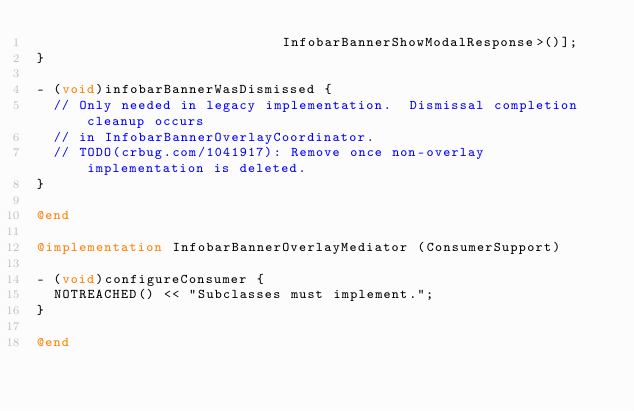<code> <loc_0><loc_0><loc_500><loc_500><_ObjectiveC_>                             InfobarBannerShowModalResponse>()];
}

- (void)infobarBannerWasDismissed {
  // Only needed in legacy implementation.  Dismissal completion cleanup occurs
  // in InfobarBannerOverlayCoordinator.
  // TODO(crbug.com/1041917): Remove once non-overlay implementation is deleted.
}

@end

@implementation InfobarBannerOverlayMediator (ConsumerSupport)

- (void)configureConsumer {
  NOTREACHED() << "Subclasses must implement.";
}

@end
</code> 